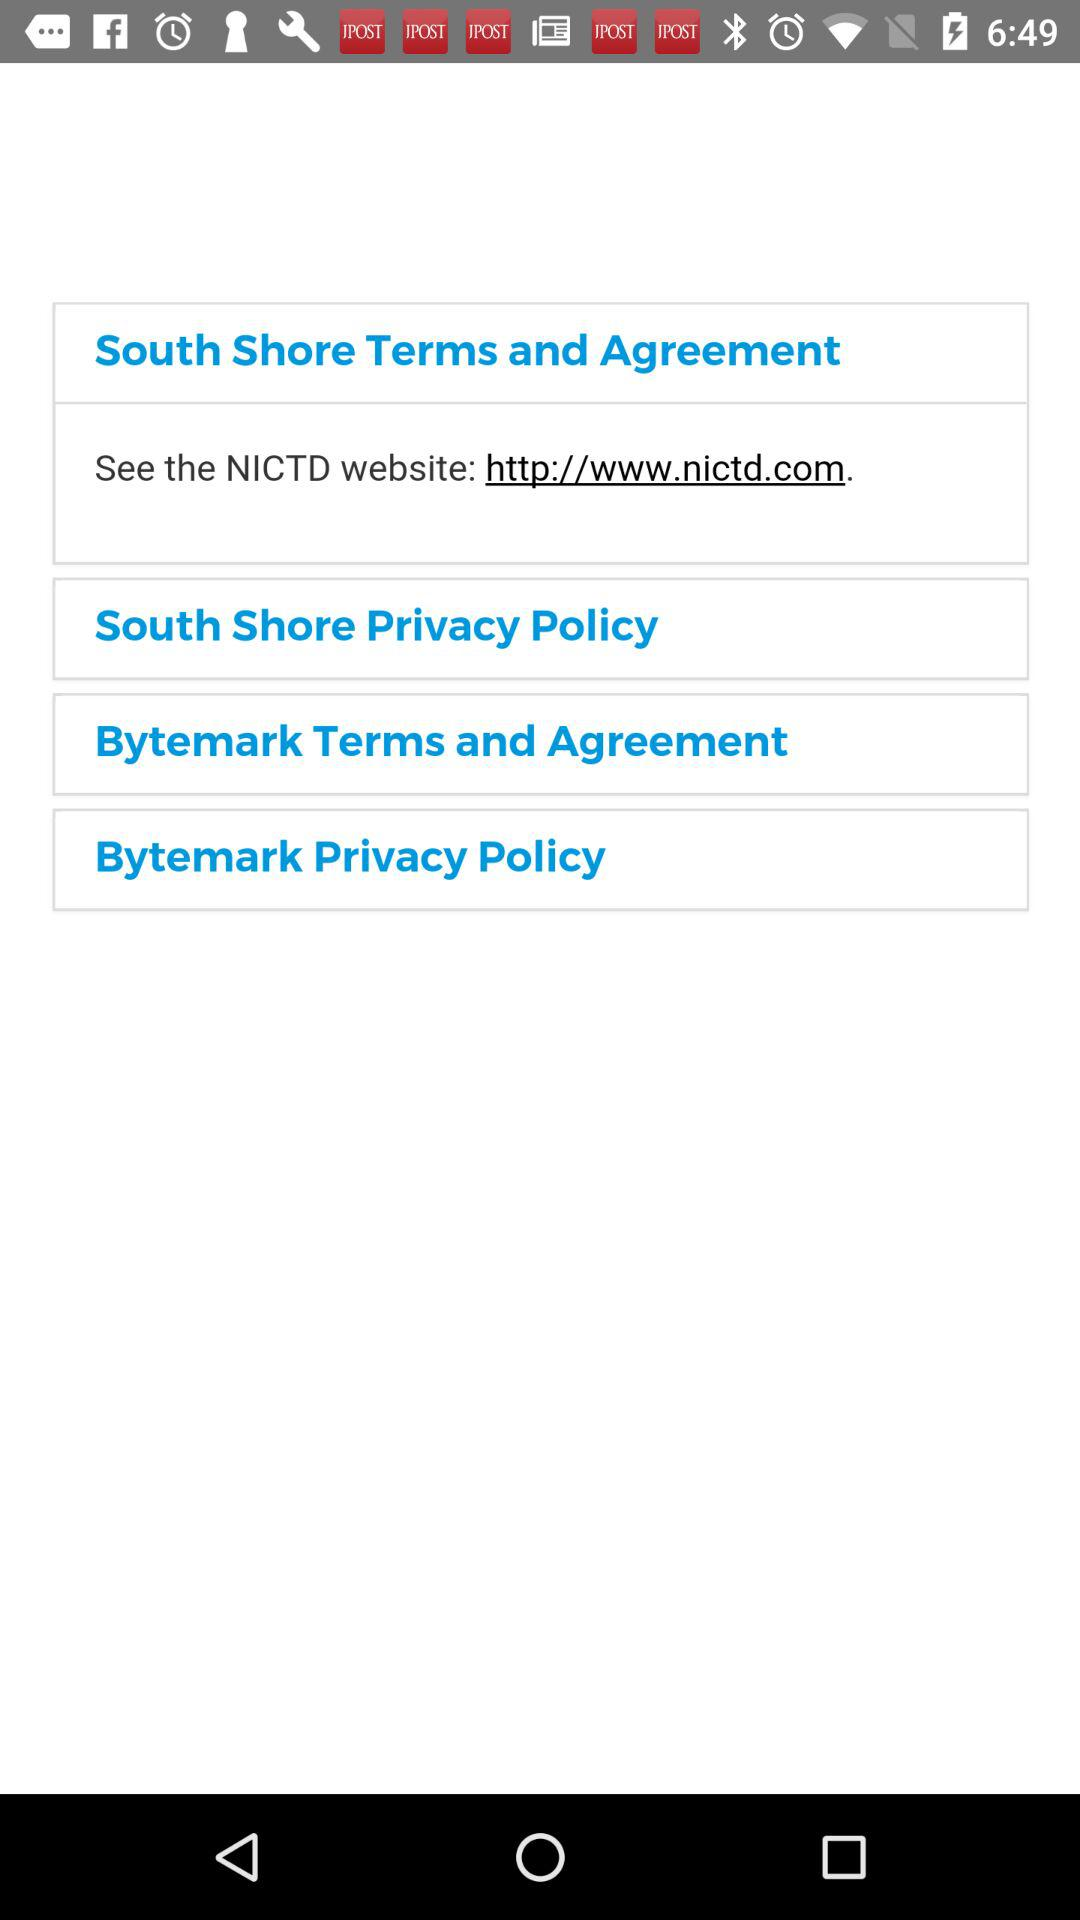How many links to other websites are there on this screen?
Answer the question using a single word or phrase. 1 